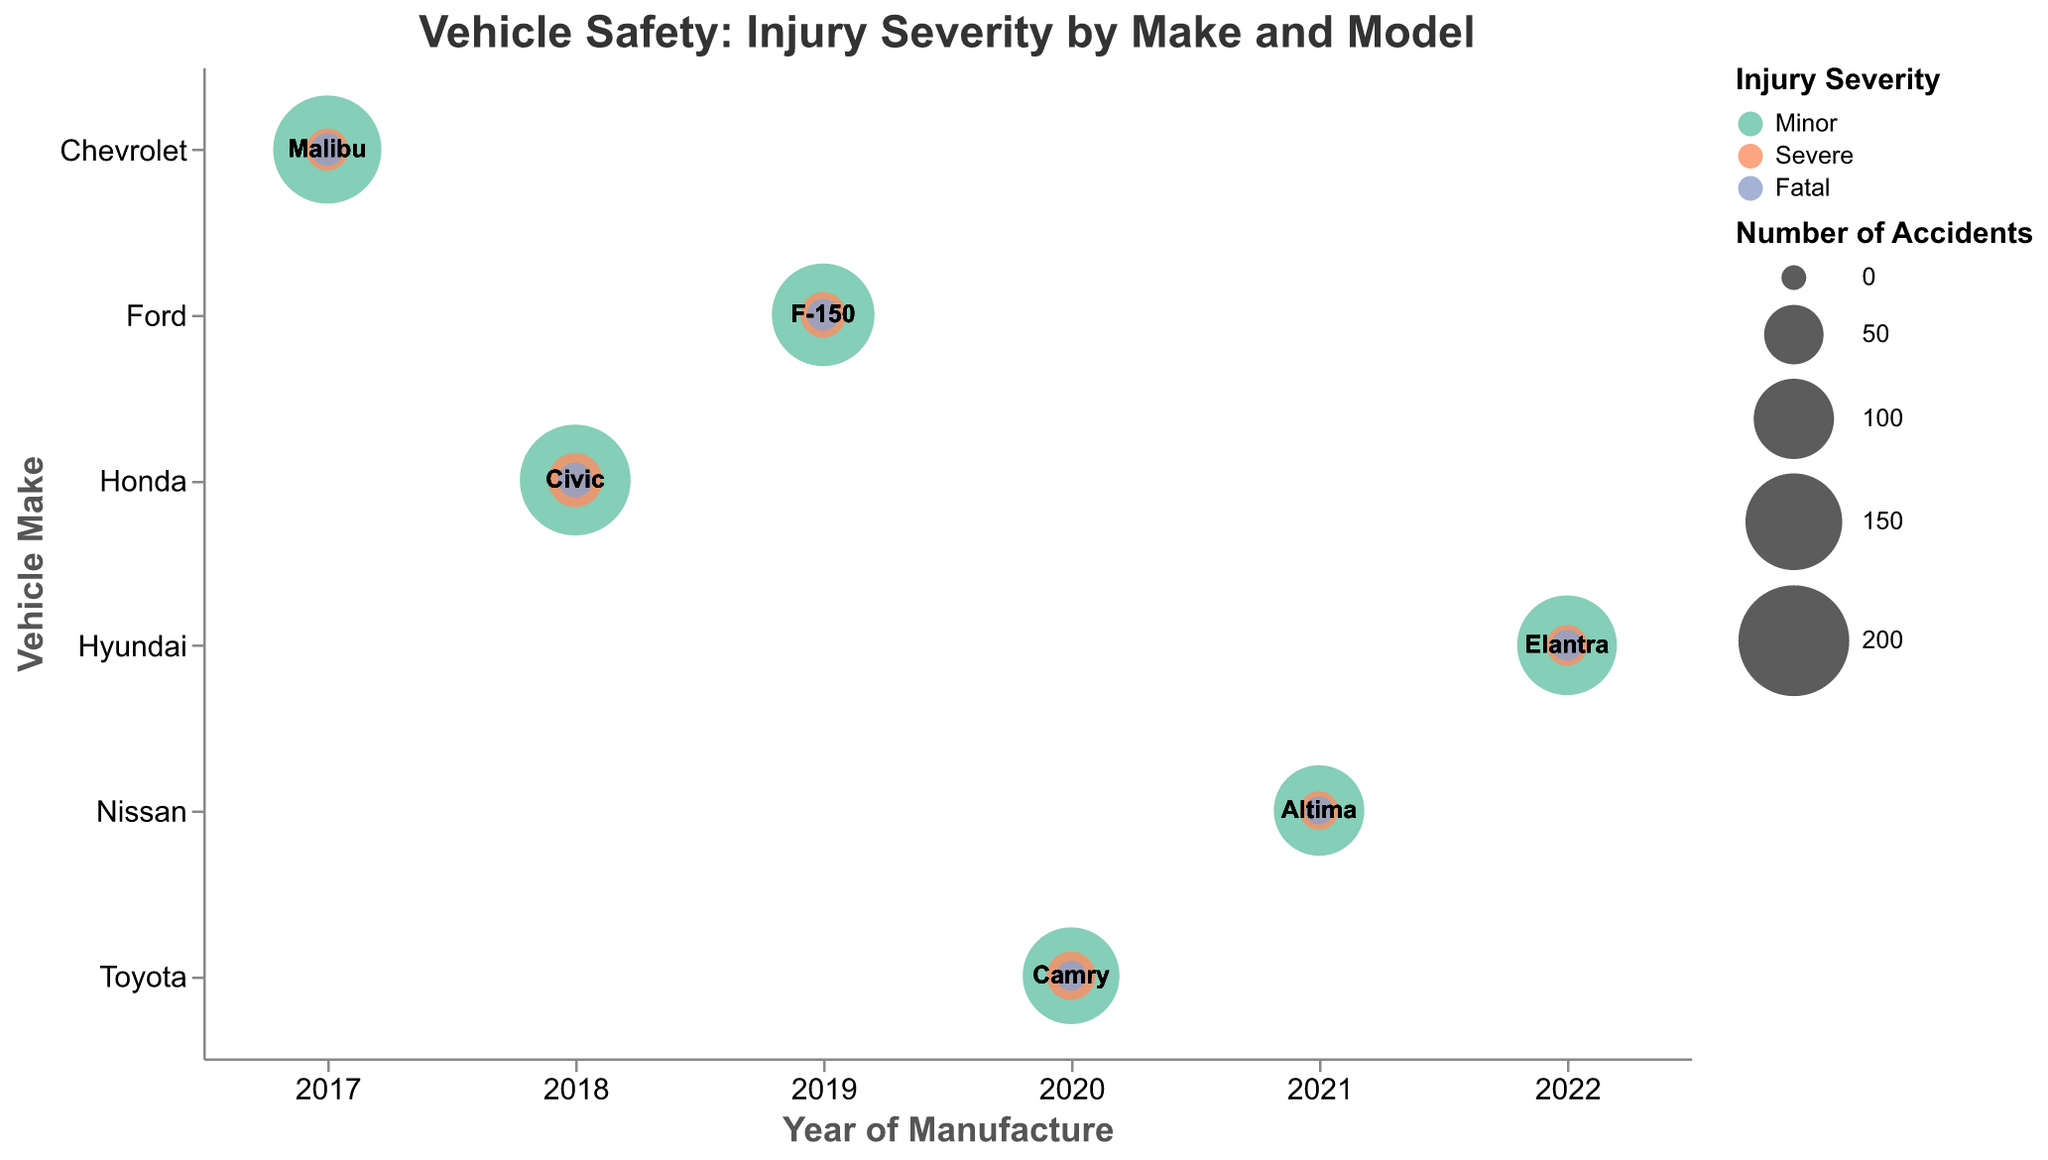How many minor injury accidents involved the Ford F-150? Locate the Ford F-150 row, look at bubbles for "Minor", find the number labeled, which is 170.
Answer: 170 Which vehicle make and model under Advanced Airbags had the lowest number of fatal injuries? Filter the data by "Advanced Airbags", find all models, compare the number of fatal injuries, the Toyota Camry has 5 fatal injuries.
Answer: Toyota Camry How does the number of severe injuries in the Hyundai Elantra compare to the Honda Civic? Find severe injury bubbles for both Hyundai Elantra and Honda Civic, compare values, the Hyundai Elantra has 18 while Honda Civic has 40.
Answer: Hyundai Elantra has fewer severe injuries than the Honda Civic Which vehicle make had the highest number of accidents with minor injuries in 2018? Filter by year 2018, look at each vehicle make for "Minor" injuries, the Honda Civic has 200 accidents.
Answer: Honda Civic Considering vehicles with electronic stability control, how many total injuries were fatal? Filter by "Electronic Stability Control", add up fatal injuries across all models and years, 8 fatal injuries for Chevrolet Malibu.
Answer: 8 What is the relationship between the implementation of Lane Departure Warning and the number of severe injuries in the Nissan Altima? Look at the Nissan Altima row, find "Lane Departure Warning" and "Severe" injuries, see if severe injuries are low due to the safety feature.
Answer: The model with Lane Departure Warning had 15 severe injuries Which make and model in 2022 had the fewest accidents with minor injuries? Filter by year 2022, find all minor injury bubbles, compare their values, Hyundai Elantra has 160 accidents with minor injuries.
Answer: Hyundai Elantra How many total accidents (all severities) did the Ford F-150 have in 2019? Find Ford F-150 row for 2019, sum the number of accidents across all severities: 170 (minor) + 25 (severe) + 7 (fatal) = 202 accidents.
Answer: 202 What is the percentage of fatal injuries for the Toyota Camry in 2020 among all types of injuries for this model and year? Sum all types of injuries for Toyota Camry in 2020 (150 minor + 30 severe + 5 fatal = 185), divide fatalities by total (5/185), multiply by 100 to get percentage.
Answer: About 2.7% Does the implementation of side-impact bars in the Honda Civic correlate with a high or low number of severe injuries? Check number of severe injuries for Honda Civic with side-impact bars, compare to other models/technologies, Honda Civic has 40 severe injuries, higher compared to several other models.
Answer: Higher 